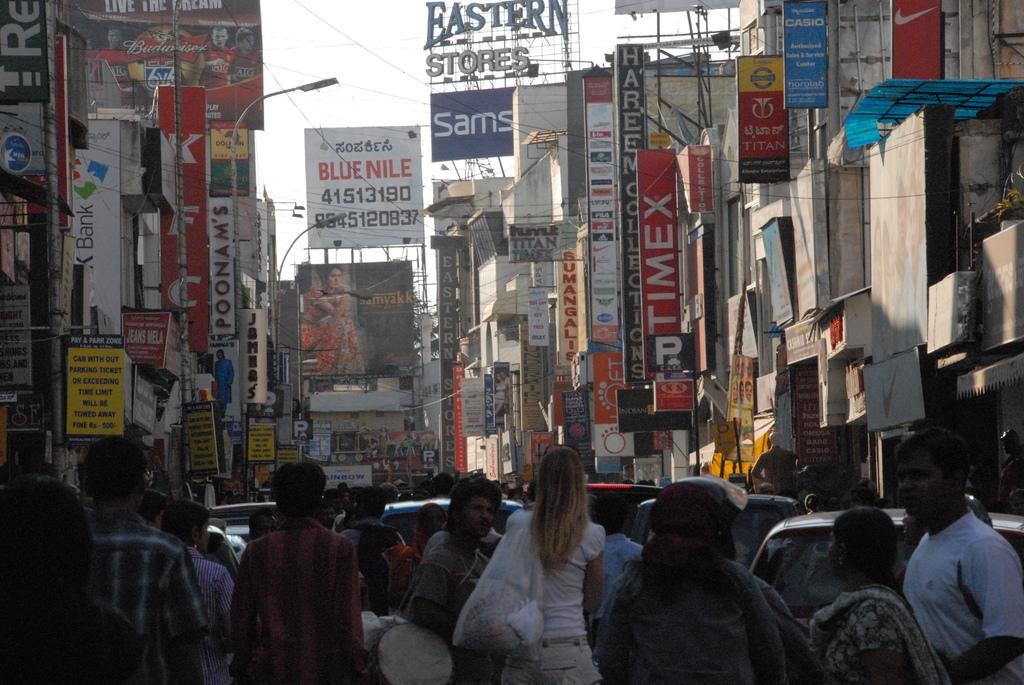Could you give a brief overview of what you see in this image? In this image in front there are people. Behind them there are cars. There are boards, banners, street lights, buildings and sky. 